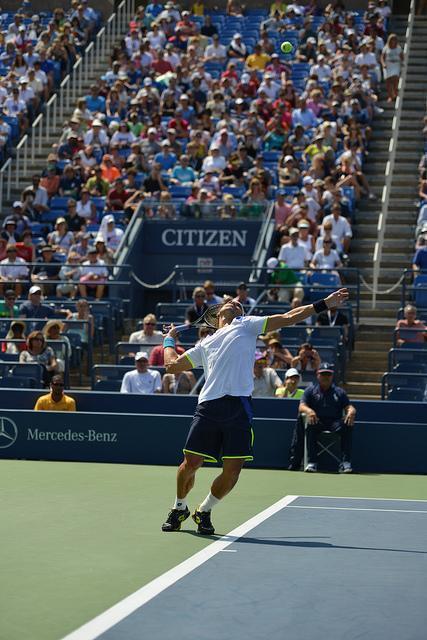What type action is the tennis player here doing?
Indicate the correct response by choosing from the four available options to answer the question.
Options: Judging, return, serving, resting. Serving. 